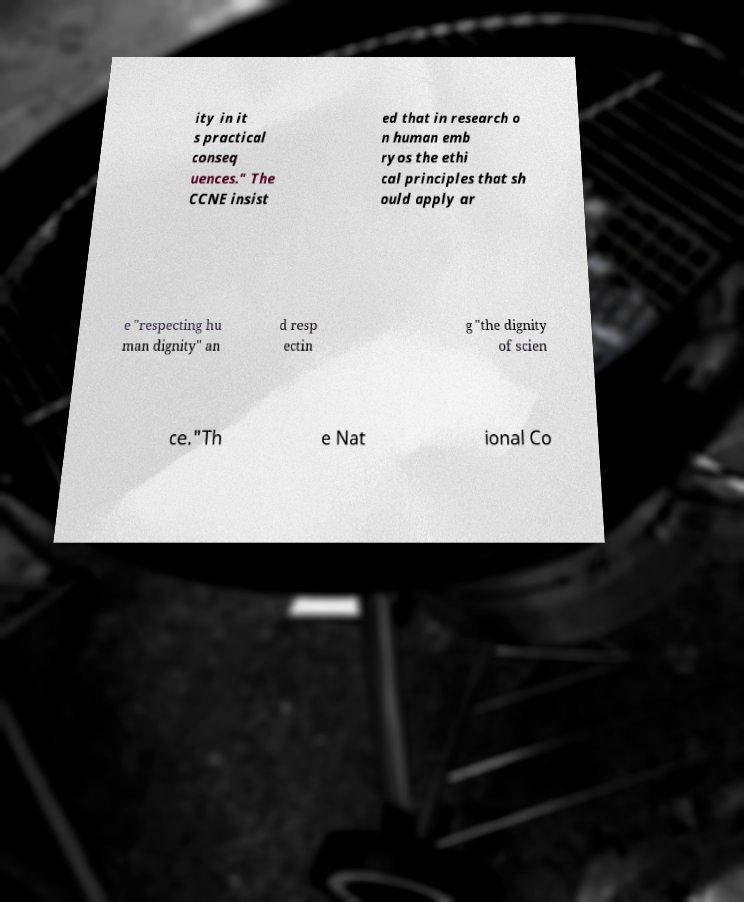There's text embedded in this image that I need extracted. Can you transcribe it verbatim? ity in it s practical conseq uences." The CCNE insist ed that in research o n human emb ryos the ethi cal principles that sh ould apply ar e "respecting hu man dignity" an d resp ectin g "the dignity of scien ce."Th e Nat ional Co 